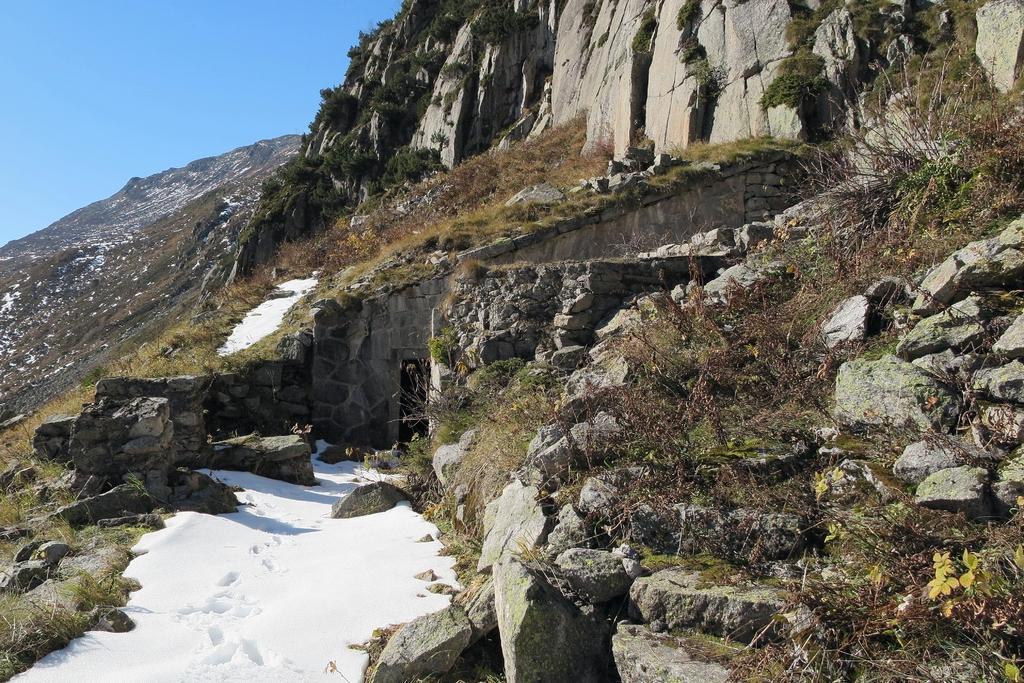Could you give a brief overview of what you see in this image? In this image there are mountains, snow, grass, plants and in the background there is the sky. 